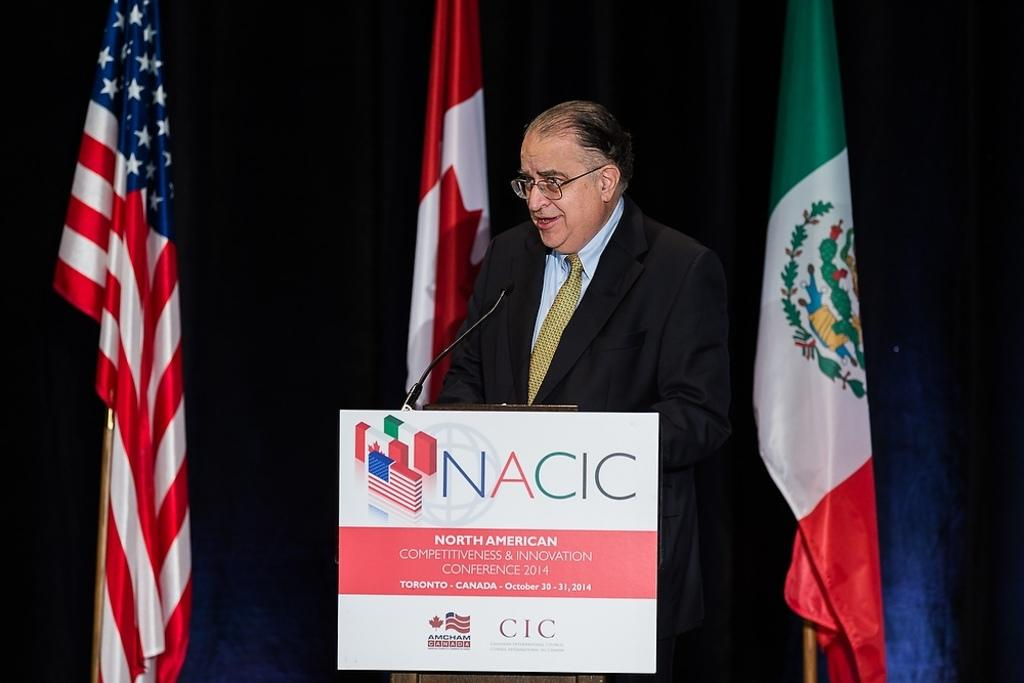Who is the main subject in the image? There is a man standing in the center of the image. What is the man standing in front of? There is a podium in front of the man. What is placed on the podium? A microphone is placed on the podium. What type of music can be heard coming from the man's sneeze in the image? There is no sneeze or music present in the image; it features a man standing in front of a podium with a microphone. How many spiders are visible on the man's shoulder in the image? There are no spiders visible on the man's shoulder in the image. 